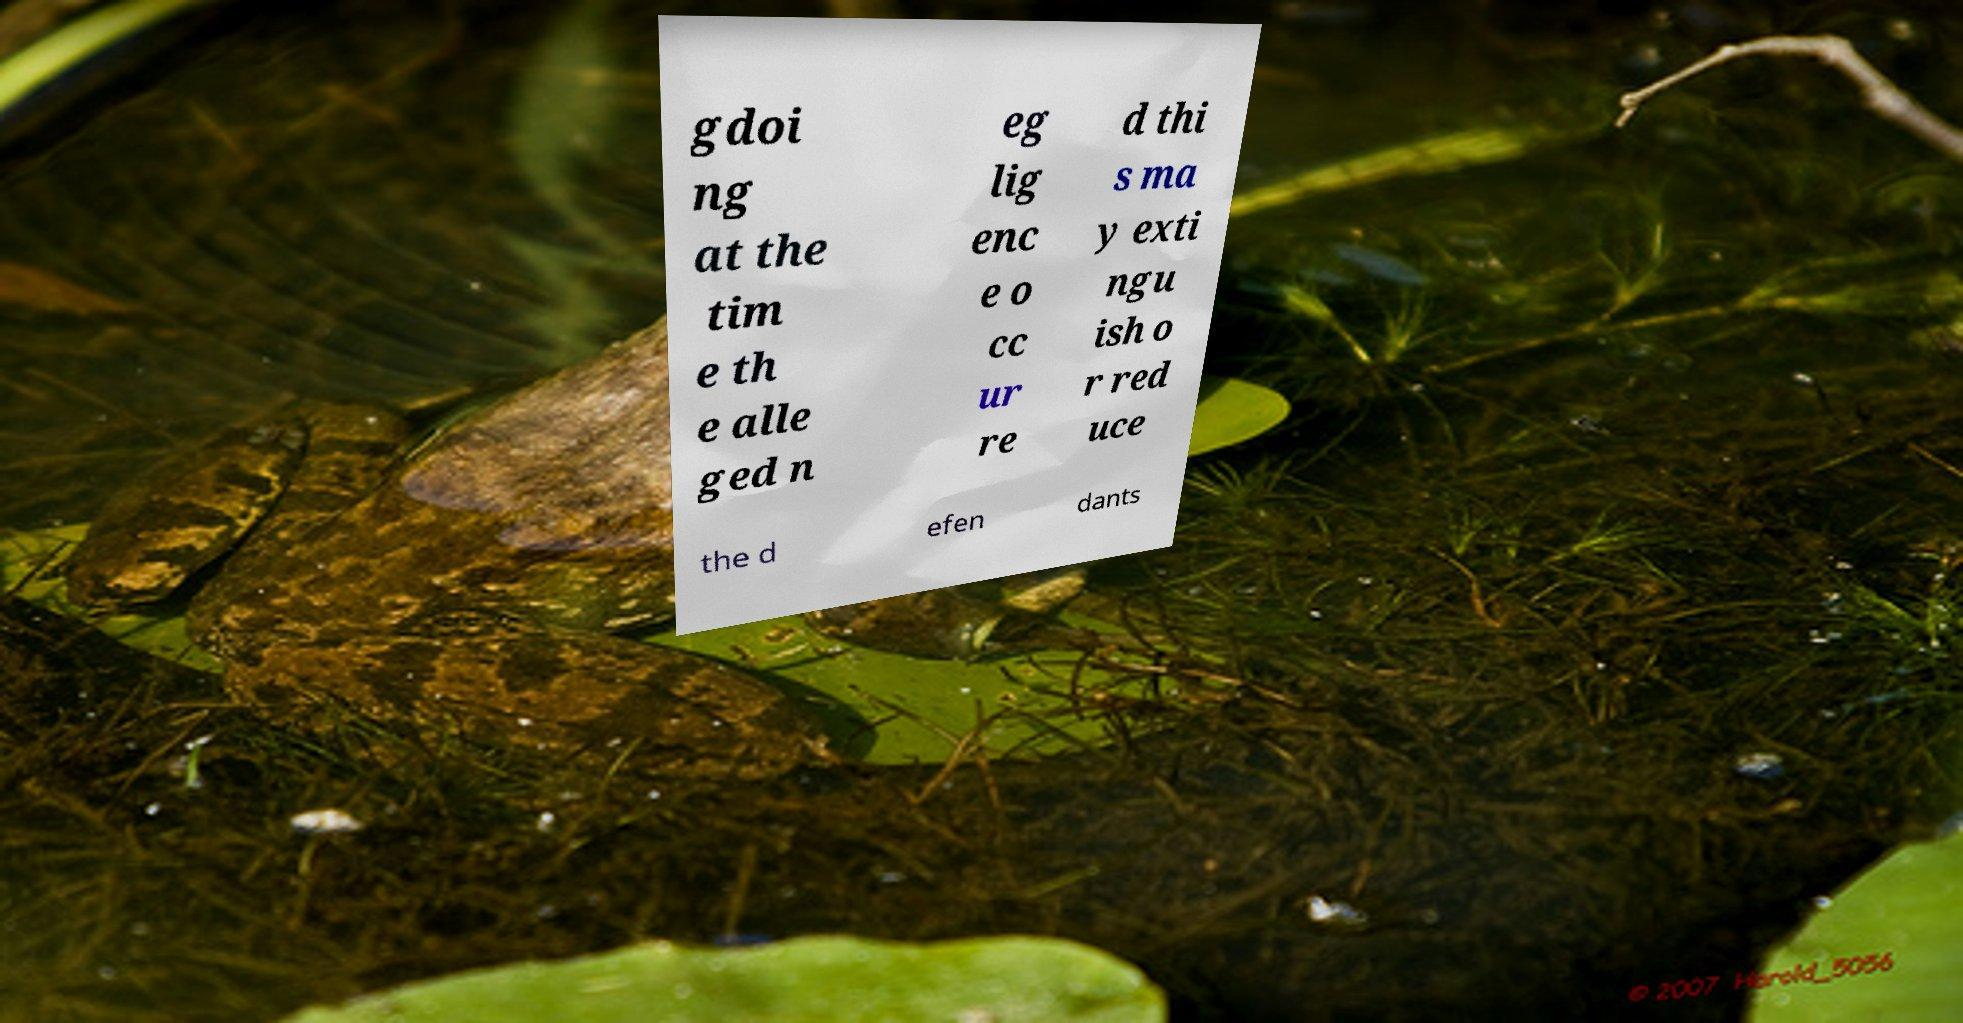Could you assist in decoding the text presented in this image and type it out clearly? gdoi ng at the tim e th e alle ged n eg lig enc e o cc ur re d thi s ma y exti ngu ish o r red uce the d efen dants 